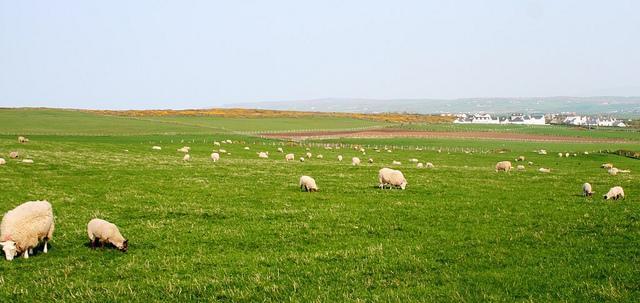How many sheep are in the photo?
Give a very brief answer. 2. How many people are using a cell phone in the image?
Give a very brief answer. 0. 